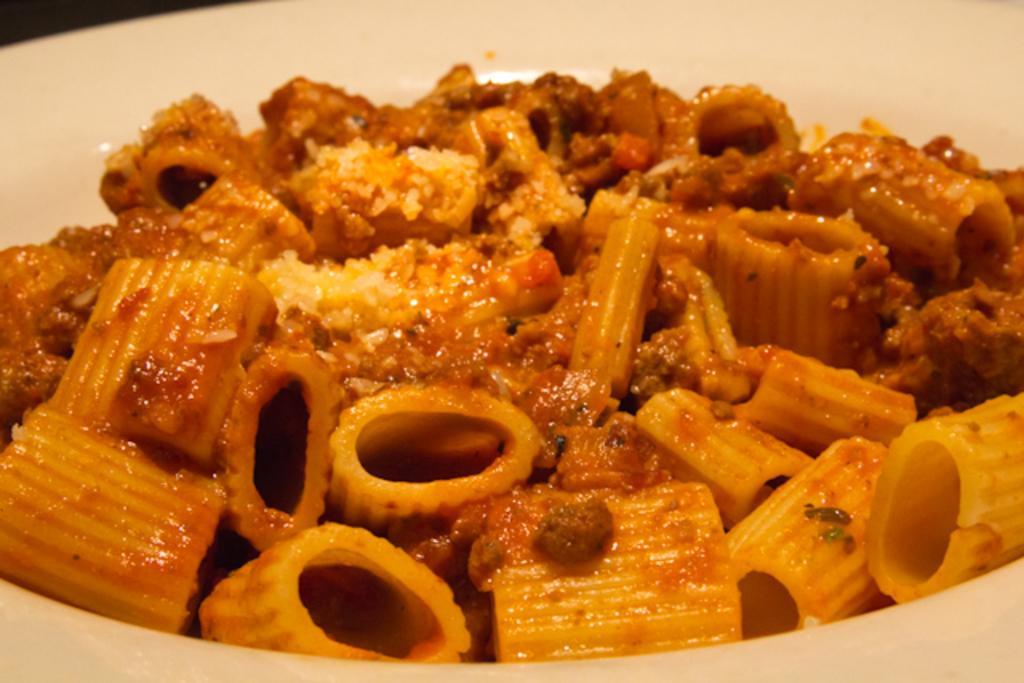Please provide a concise description of this image. In this picture we can see a white bowl in which there is delicious pasta. 